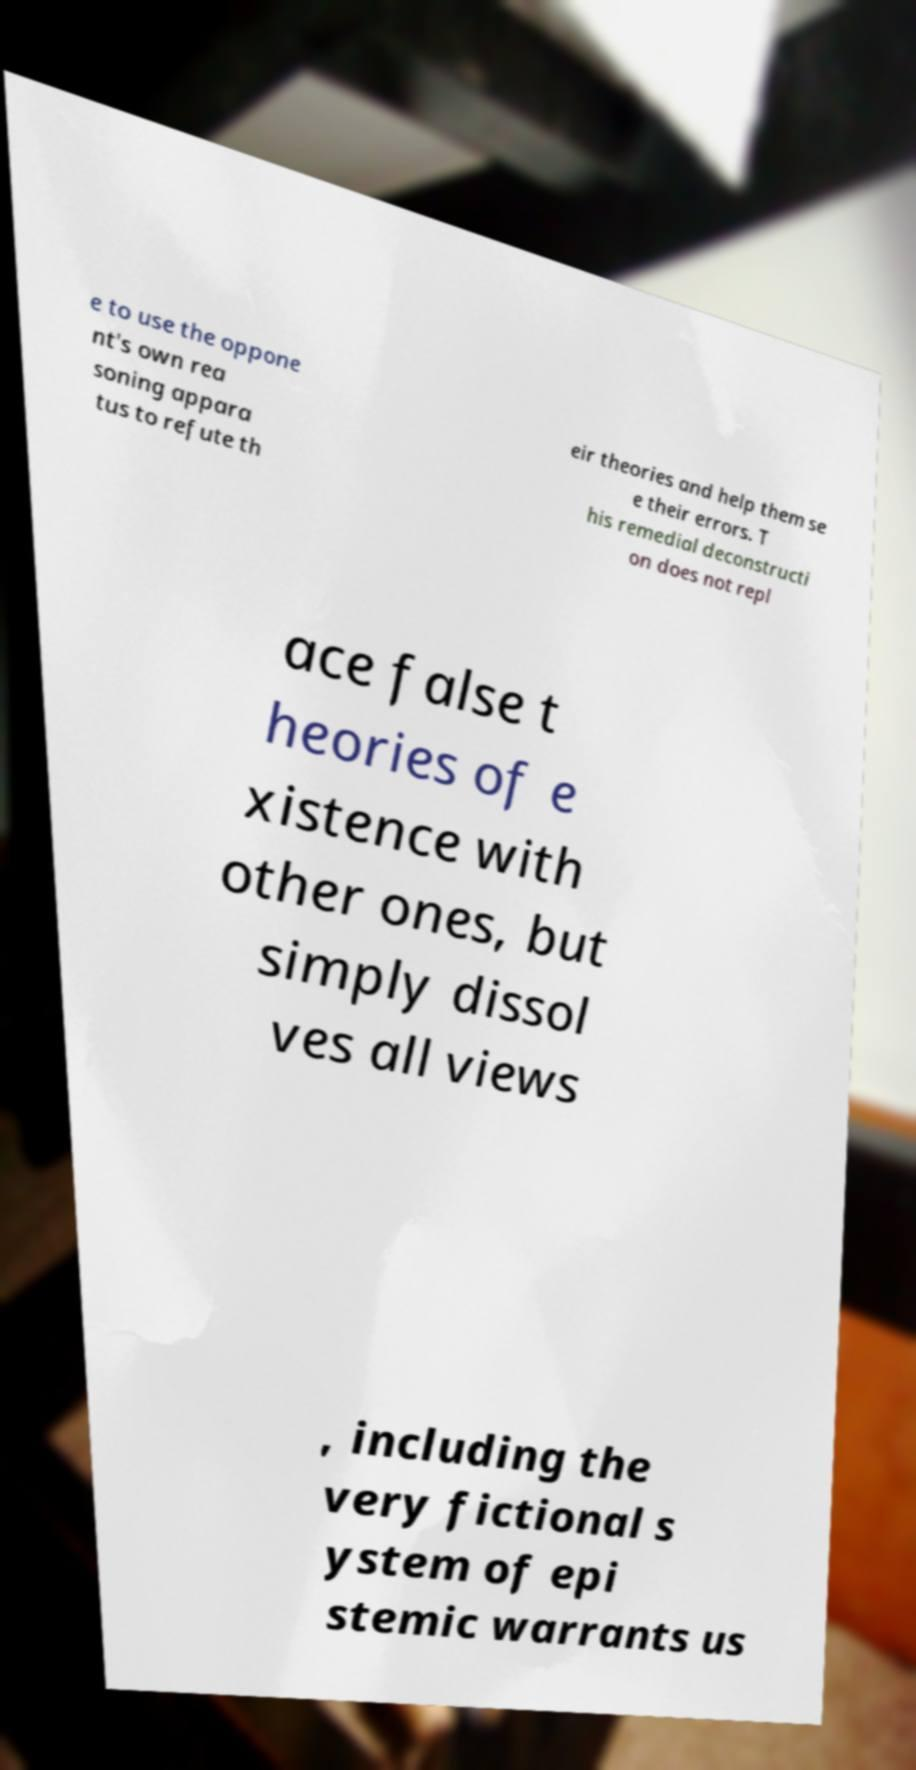Could you assist in decoding the text presented in this image and type it out clearly? e to use the oppone nt's own rea soning appara tus to refute th eir theories and help them se e their errors. T his remedial deconstructi on does not repl ace false t heories of e xistence with other ones, but simply dissol ves all views , including the very fictional s ystem of epi stemic warrants us 